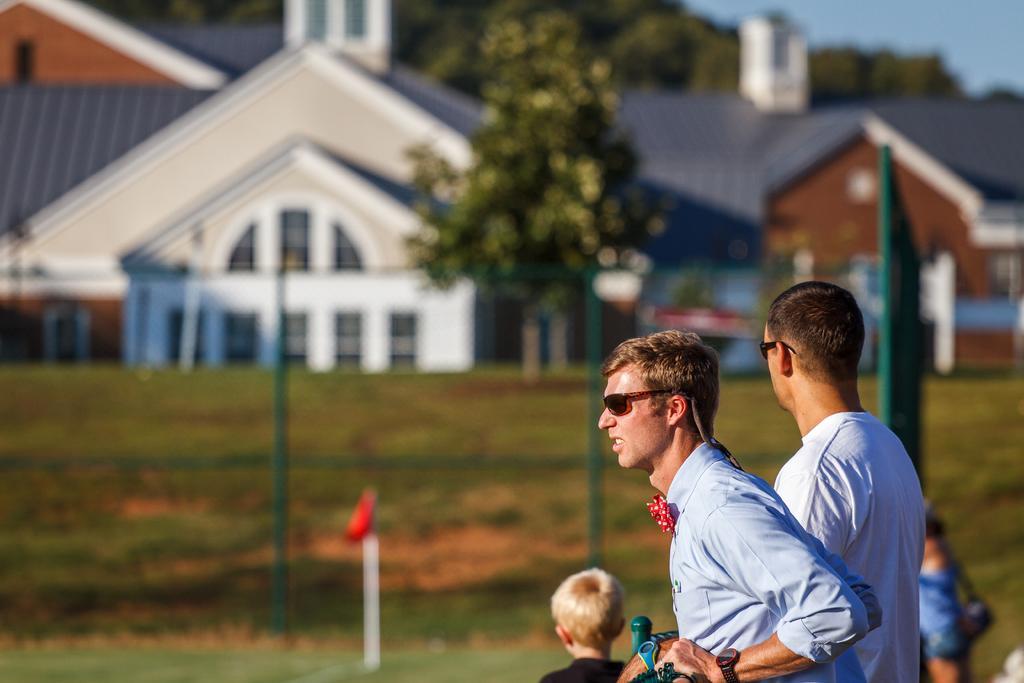Can you describe this image briefly? On the right side two men are there and looking at this side, in the middle there is a house. There are trees in this image. 